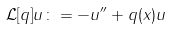Convert formula to latex. <formula><loc_0><loc_0><loc_500><loc_500>\mathcal { L } [ q ] u \colon = - u ^ { \prime \prime } + q ( x ) u \,</formula> 